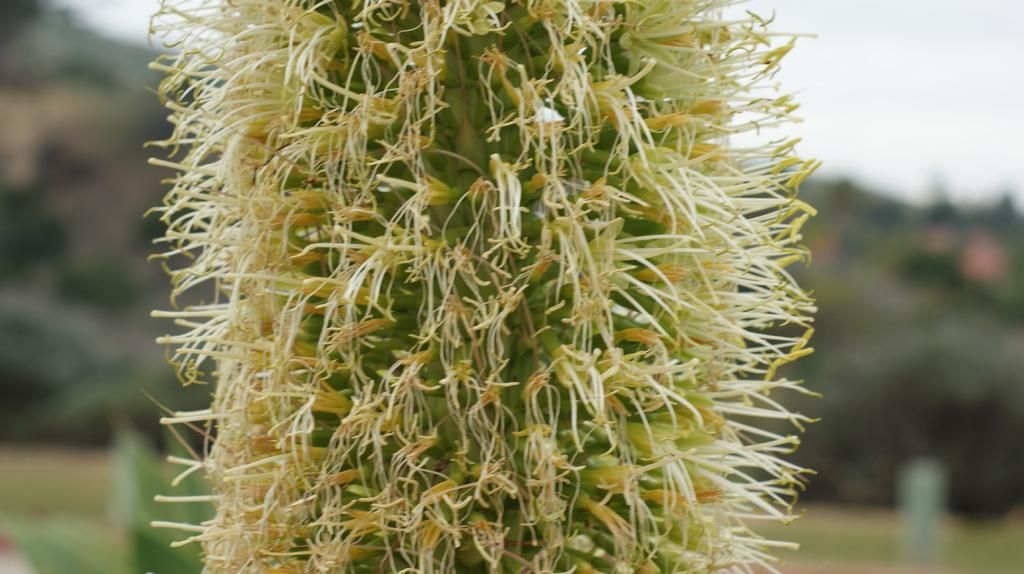What is the main subject in the image? There is a plant in the image. Can you describe the background of the image? The background of the image is blurred. How many zebras can be seen in the image? There are no zebras present in the image. What level of detail is visible in the background of the image? The background of the image is blurred, so it is difficult to discern specific details. 